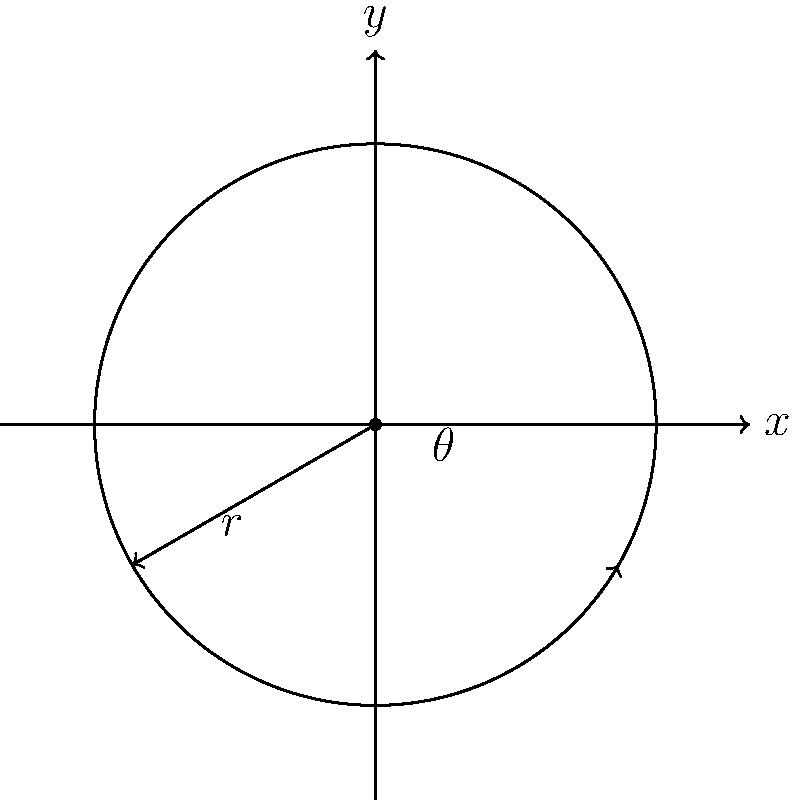As an aspiring sports reporter, you're covering a track event at your high school. The circular track has a radius of 50 meters. A runner starts at the easternmost point of the track and runs counterclockwise for 60 degrees along the track's circumference. Using polar coordinates, calculate the distance the runner has covered. Let's approach this step-by-step:

1) In polar coordinates, the formula for arc length is:

   $$s = r\theta$$

   Where:
   $s$ is the arc length (distance covered)
   $r$ is the radius of the circle
   $\theta$ is the angle in radians

2) We're given:
   $r = 50$ meters
   $\theta = 60°$

3) However, we need to convert the angle from degrees to radians:

   $$\theta_{radians} = \theta_{degrees} \times \frac{\pi}{180°}$$

   $$\theta_{radians} = 60° \times \frac{\pi}{180°} = \frac{\pi}{3}$$

4) Now we can plug these values into our arc length formula:

   $$s = r\theta$$
   $$s = 50 \times \frac{\pi}{3}$$

5) Simplify:

   $$s = \frac{50\pi}{3} \approx 52.36$$

Therefore, the runner has covered approximately 52.36 meters.
Answer: $\frac{50\pi}{3}$ meters 